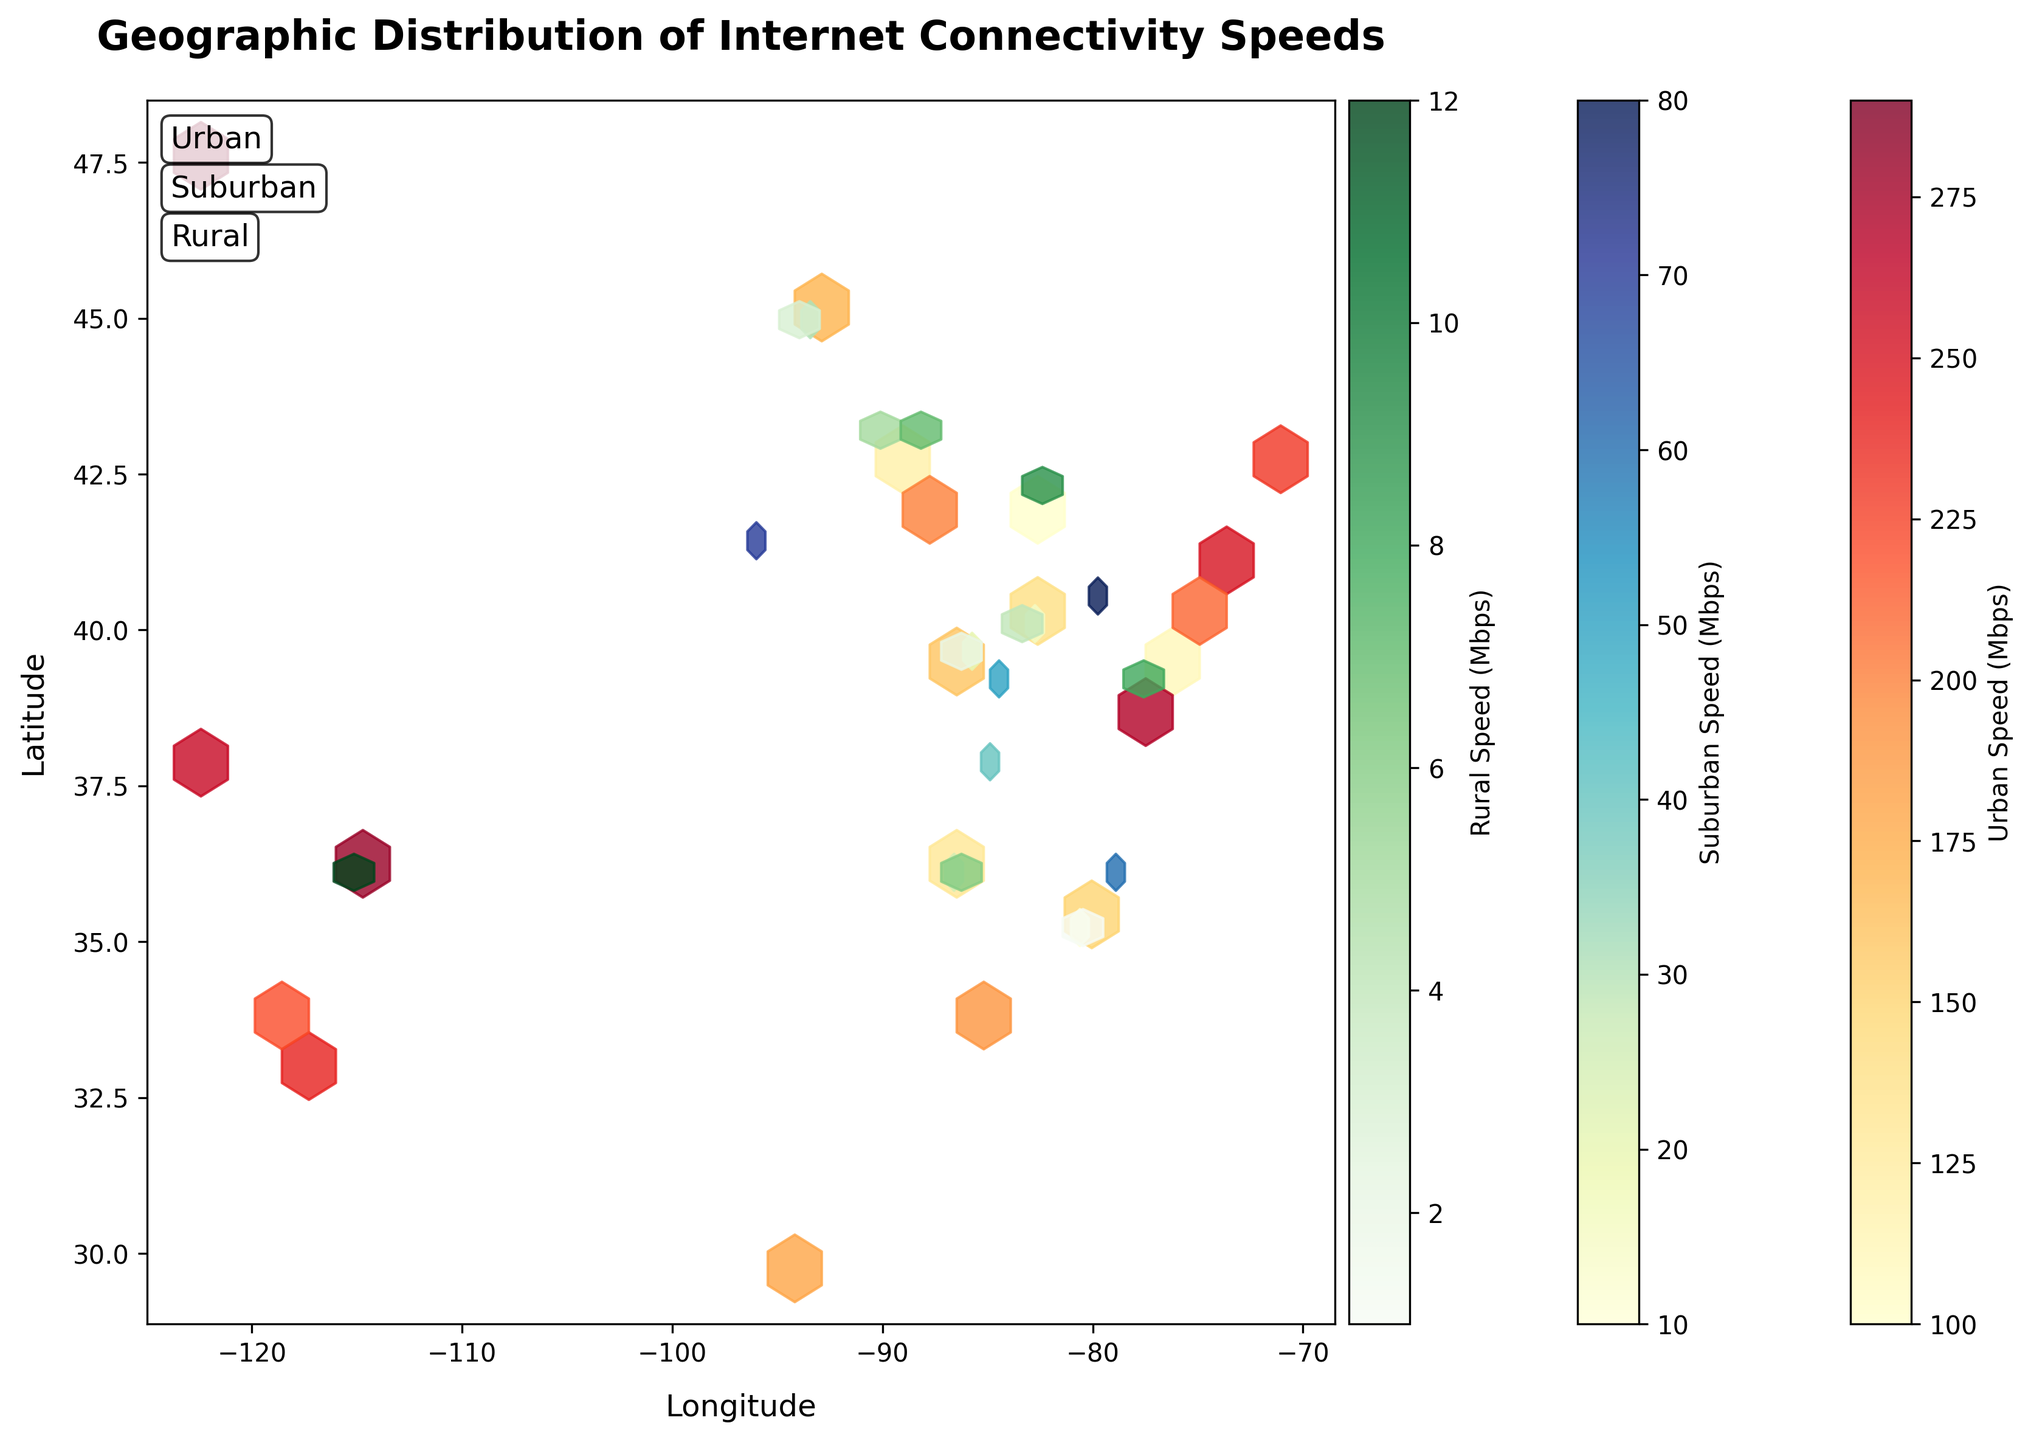What's the title of the Hexbin plot? The title is displayed at the top of the plot in a larger and bold font.
Answer: Geographic Distribution of Internet Connectivity Speeds What does the color bar labelled 'Urban Speed (Mbps)' represent? The color bar represents the internet speed in Mbps for urban areas. The colors range from light yellow to dark red.
Answer: Internet Speed in Urban Areas What does the 'Longitude' label on the x-axis indicate? The x-axis labeled 'Longitude' indicates the horizontal geographical coordinate. The plot visually maps data points based on their longitudes.
Answer: Horizontal geographical coordinate What is the internet speed range for rural areas as represented by the color bar? The color bar for rural areas ranges from a light green color to a darker green color, indicating the difference in Mbps speed values.
Answer: Varies from light to dark green How do internet speeds generally compare between urban and rural areas? By observing the different color intensities on the plot, urban areas (YlOrRd color map) generally show higher internet speeds as darker colors compared to rural areas (Greens color map).
Answer: Urban areas have higher speeds Which type of area shows the hexbin with the darkest color in the entire plot? The darkest colored hexbin represents the highest speed, and it is located in the urban area (red color hexbin at 47.6062, -122.3321).
Answer: Urban How many separate color bars are included in the plot and what do they represent? There are three separate color bars, each representing the internet speed for 'Urban', 'Suburban', and 'Rural' areas with different color mappings.
Answer: Three: Urban (YlOrRd), Suburban (YlGnBu), and Rural (Greens) Based on the plot, which general area has the lowest recorded internet speed and what is that speed? The lowest internet speed is found in a rural area marked by the lightest green hexbin, specifically at the datapoint (43.0731, -89.4012) representing a speed of 5 Mbps.
Answer: Rural, 5 Mbps What's the significance of the different text labels ('Urban', 'Suburban', 'Rural') on the plot? These labels help to visually distinguish and identify the different area types represented by the hexbin color mappings in the plot.
Answer: Identify area types Which hexbin color map seems to have the widest range of internet speeds? The plot's urban area color map (YlOrRd) has a noticeable wide range of colors from light yellow to dark red, indicating a wider range of internet speeds.
Answer: Urban area 